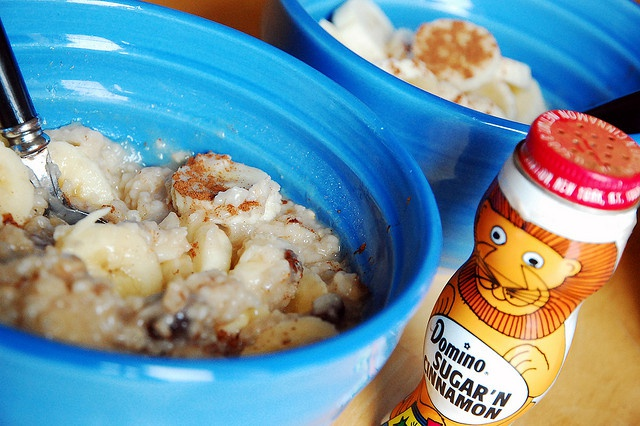Describe the objects in this image and their specific colors. I can see bowl in lightblue, tan, and darkgray tones, bowl in lightblue, blue, and lightgray tones, bottle in lightblue, white, red, orange, and gold tones, dining table in lightblue, tan, maroon, and brown tones, and banana in lightblue, lightgray, brown, and darkgray tones in this image. 